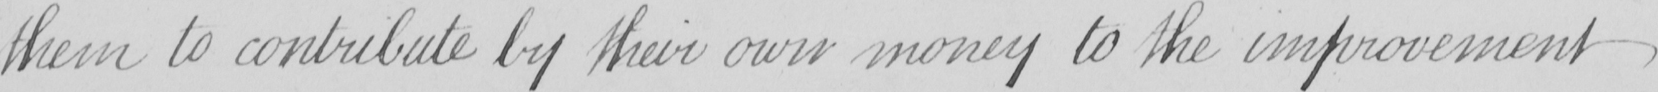Transcribe the text shown in this historical manuscript line. them to contribute by their own money to the improvement 